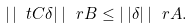Convert formula to latex. <formula><loc_0><loc_0><loc_500><loc_500>| \, | \ t C \delta | \, | _ { \ } r B \leq | \, | \delta | \, | _ { \ } r A .</formula> 